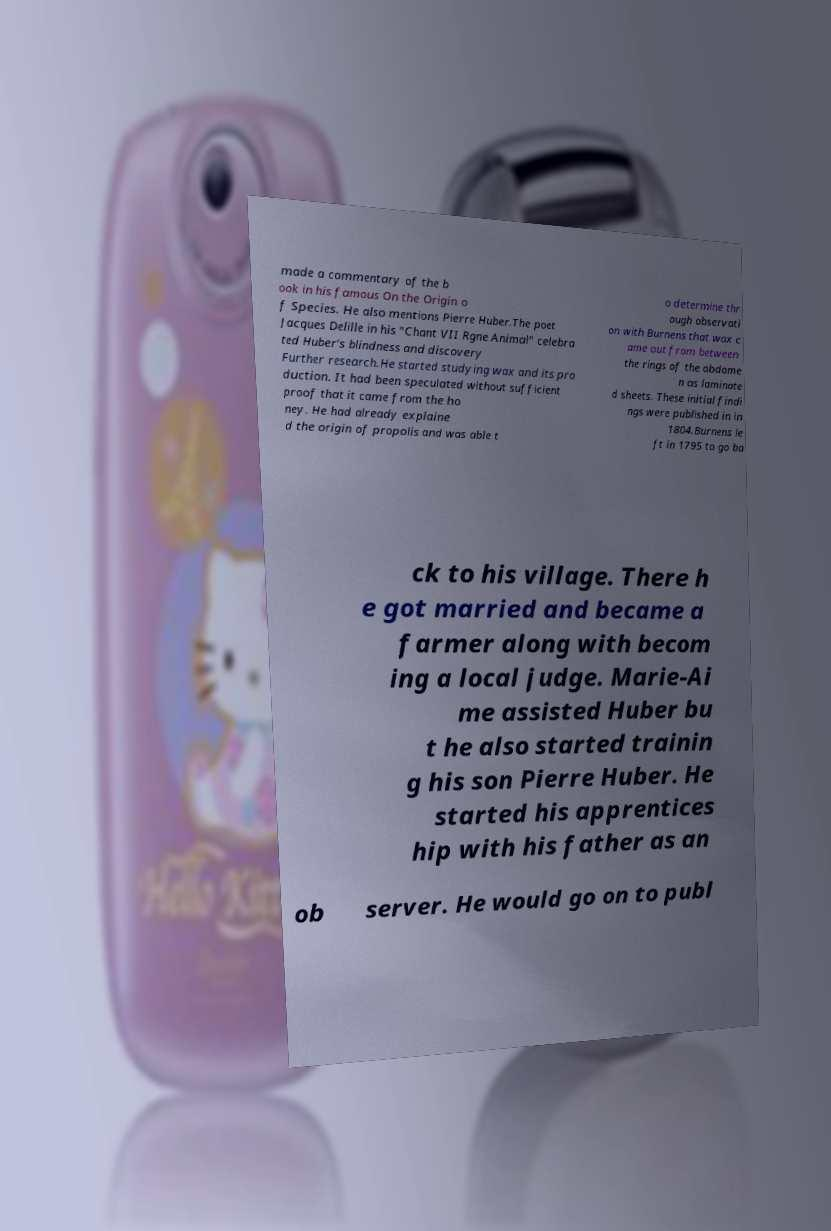Can you accurately transcribe the text from the provided image for me? made a commentary of the b ook in his famous On the Origin o f Species. He also mentions Pierre Huber.The poet Jacques Delille in his "Chant VII Rgne Animal" celebra ted Huber's blindness and discovery Further research.He started studying wax and its pro duction. It had been speculated without sufficient proof that it came from the ho ney. He had already explaine d the origin of propolis and was able t o determine thr ough observati on with Burnens that wax c ame out from between the rings of the abdome n as laminate d sheets. These initial findi ngs were published in in 1804.Burnens le ft in 1795 to go ba ck to his village. There h e got married and became a farmer along with becom ing a local judge. Marie-Ai me assisted Huber bu t he also started trainin g his son Pierre Huber. He started his apprentices hip with his father as an ob server. He would go on to publ 